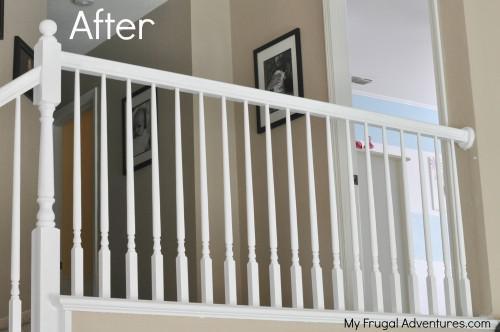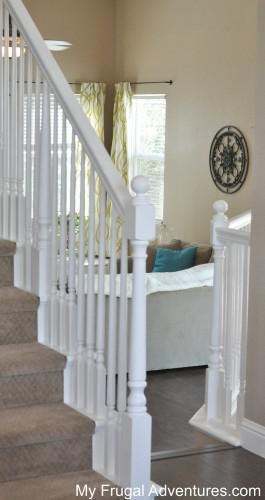The first image is the image on the left, the second image is the image on the right. Given the left and right images, does the statement "The left image shows one non-turning flight of carpeted stairs, with spindle rails and a ball atop the end post." hold true? Answer yes or no. No. 